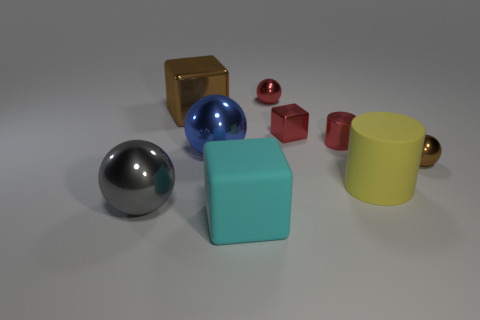What might be the purpose of the arrangement of these objects? The arrangement of the objects appears to be intentionally designed to display a variety of shapes, colors, and textures, which may serve an educational or illustrative purpose. It could be part of a visual study in geometry or an artistic composition to explore light and reflections. 